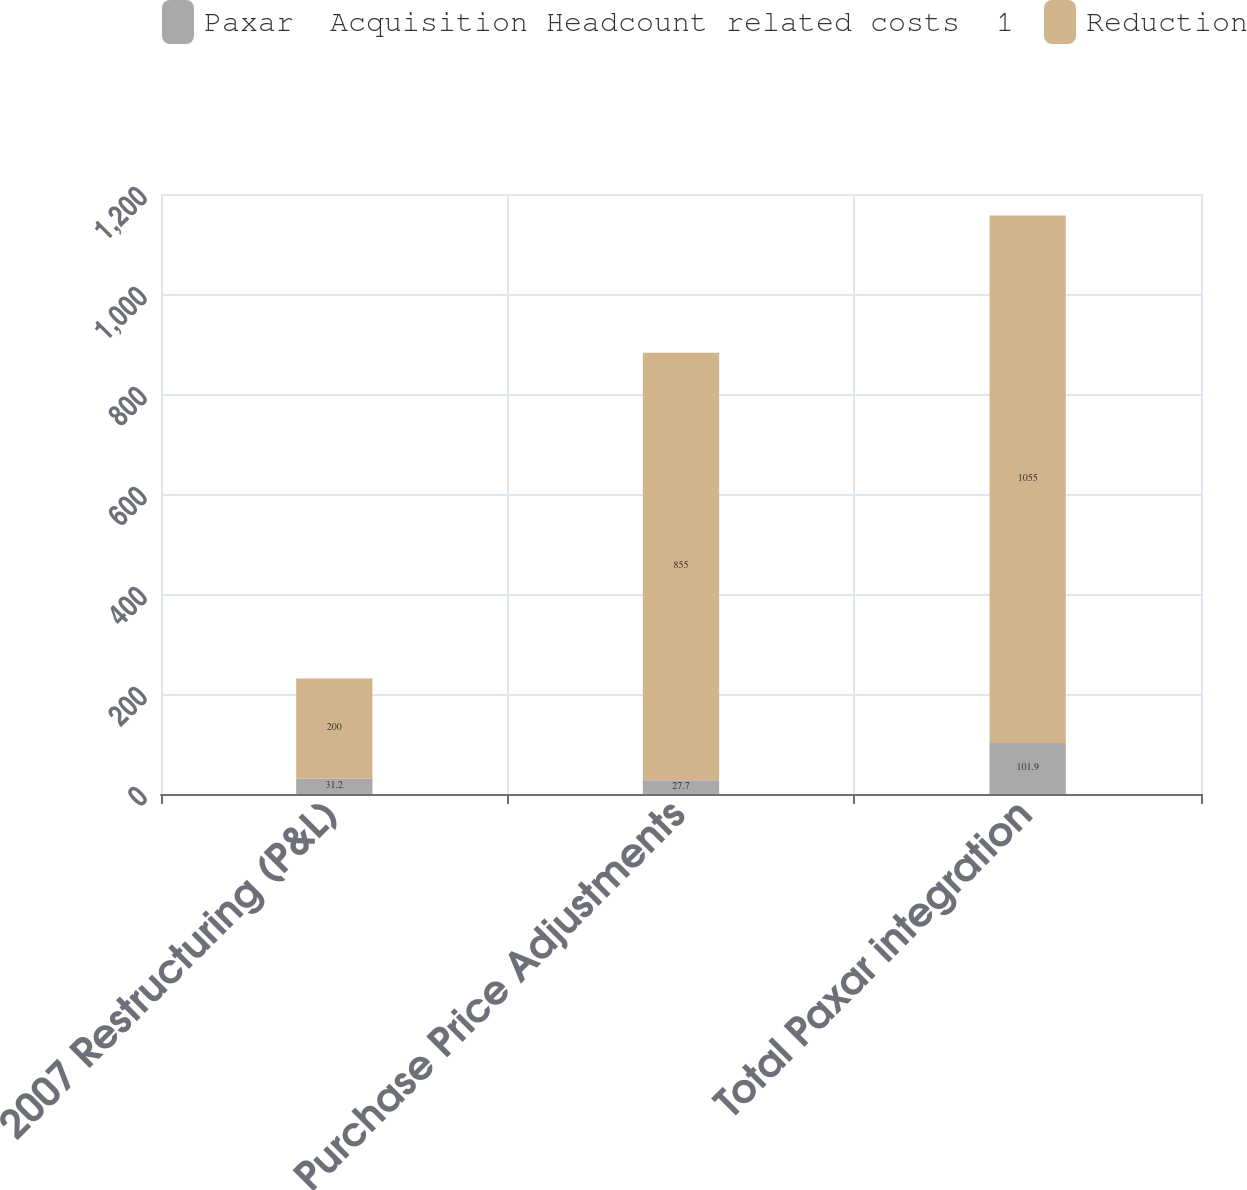Convert chart to OTSL. <chart><loc_0><loc_0><loc_500><loc_500><stacked_bar_chart><ecel><fcel>2007 Restructuring (P&L)<fcel>Purchase Price Adjustments<fcel>Total Paxar integration<nl><fcel>Paxar  Acquisition Headcount related costs  1<fcel>31.2<fcel>27.7<fcel>101.9<nl><fcel>Reduction<fcel>200<fcel>855<fcel>1055<nl></chart> 